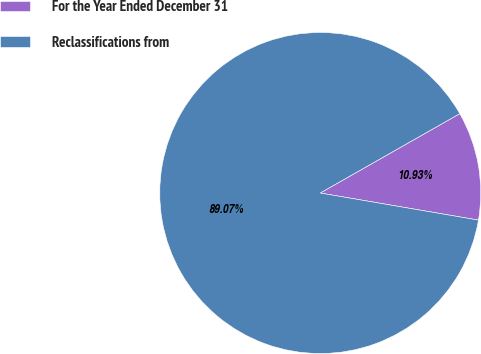<chart> <loc_0><loc_0><loc_500><loc_500><pie_chart><fcel>For the Year Ended December 31<fcel>Reclassifications from<nl><fcel>10.93%<fcel>89.07%<nl></chart> 